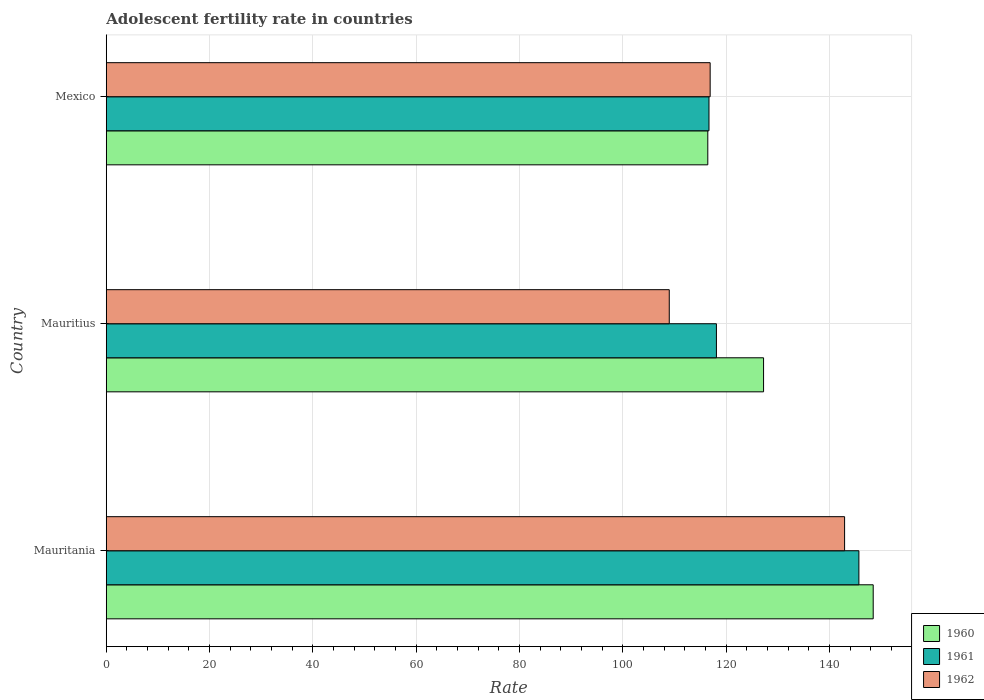Are the number of bars per tick equal to the number of legend labels?
Keep it short and to the point. Yes. Are the number of bars on each tick of the Y-axis equal?
Your answer should be very brief. Yes. What is the label of the 3rd group of bars from the top?
Offer a terse response. Mauritania. What is the adolescent fertility rate in 1962 in Mauritania?
Offer a very short reply. 142.93. Across all countries, what is the maximum adolescent fertility rate in 1960?
Provide a short and direct response. 148.47. Across all countries, what is the minimum adolescent fertility rate in 1960?
Your answer should be compact. 116.45. In which country was the adolescent fertility rate in 1960 maximum?
Offer a very short reply. Mauritania. In which country was the adolescent fertility rate in 1962 minimum?
Offer a terse response. Mauritius. What is the total adolescent fertility rate in 1960 in the graph?
Make the answer very short. 392.17. What is the difference between the adolescent fertility rate in 1961 in Mauritania and that in Mauritius?
Your answer should be compact. 27.58. What is the difference between the adolescent fertility rate in 1962 in Mauritania and the adolescent fertility rate in 1960 in Mexico?
Keep it short and to the point. 26.48. What is the average adolescent fertility rate in 1962 per country?
Make the answer very short. 122.95. What is the difference between the adolescent fertility rate in 1962 and adolescent fertility rate in 1960 in Mauritania?
Keep it short and to the point. -5.54. What is the ratio of the adolescent fertility rate in 1960 in Mauritania to that in Mexico?
Give a very brief answer. 1.27. Is the adolescent fertility rate in 1962 in Mauritius less than that in Mexico?
Provide a short and direct response. Yes. What is the difference between the highest and the second highest adolescent fertility rate in 1962?
Offer a very short reply. 26.02. What is the difference between the highest and the lowest adolescent fertility rate in 1960?
Your answer should be very brief. 32.02. In how many countries, is the adolescent fertility rate in 1962 greater than the average adolescent fertility rate in 1962 taken over all countries?
Offer a very short reply. 1. Is the sum of the adolescent fertility rate in 1962 in Mauritania and Mauritius greater than the maximum adolescent fertility rate in 1960 across all countries?
Ensure brevity in your answer.  Yes. What does the 2nd bar from the top in Mauritania represents?
Your response must be concise. 1961. What does the 2nd bar from the bottom in Mauritania represents?
Offer a very short reply. 1961. How many bars are there?
Provide a succinct answer. 9. Are all the bars in the graph horizontal?
Offer a very short reply. Yes. What is the difference between two consecutive major ticks on the X-axis?
Provide a succinct answer. 20. Does the graph contain any zero values?
Keep it short and to the point. No. Does the graph contain grids?
Make the answer very short. Yes. Where does the legend appear in the graph?
Give a very brief answer. Bottom right. How many legend labels are there?
Offer a terse response. 3. How are the legend labels stacked?
Make the answer very short. Vertical. What is the title of the graph?
Make the answer very short. Adolescent fertility rate in countries. What is the label or title of the X-axis?
Give a very brief answer. Rate. What is the Rate of 1960 in Mauritania?
Offer a terse response. 148.47. What is the Rate in 1961 in Mauritania?
Give a very brief answer. 145.7. What is the Rate in 1962 in Mauritania?
Offer a very short reply. 142.93. What is the Rate of 1960 in Mauritius?
Offer a very short reply. 127.25. What is the Rate of 1961 in Mauritius?
Your answer should be very brief. 118.12. What is the Rate of 1962 in Mauritius?
Ensure brevity in your answer.  108.99. What is the Rate of 1960 in Mexico?
Provide a succinct answer. 116.45. What is the Rate of 1961 in Mexico?
Offer a terse response. 116.68. What is the Rate in 1962 in Mexico?
Keep it short and to the point. 116.91. Across all countries, what is the maximum Rate of 1960?
Keep it short and to the point. 148.47. Across all countries, what is the maximum Rate in 1961?
Your answer should be compact. 145.7. Across all countries, what is the maximum Rate in 1962?
Provide a short and direct response. 142.93. Across all countries, what is the minimum Rate of 1960?
Make the answer very short. 116.45. Across all countries, what is the minimum Rate in 1961?
Your response must be concise. 116.68. Across all countries, what is the minimum Rate in 1962?
Your answer should be compact. 108.99. What is the total Rate of 1960 in the graph?
Your answer should be compact. 392.17. What is the total Rate in 1961 in the graph?
Ensure brevity in your answer.  380.5. What is the total Rate in 1962 in the graph?
Offer a very short reply. 368.84. What is the difference between the Rate of 1960 in Mauritania and that in Mauritius?
Your answer should be compact. 21.23. What is the difference between the Rate of 1961 in Mauritania and that in Mauritius?
Offer a terse response. 27.58. What is the difference between the Rate in 1962 in Mauritania and that in Mauritius?
Offer a very short reply. 33.94. What is the difference between the Rate in 1960 in Mauritania and that in Mexico?
Your answer should be very brief. 32.02. What is the difference between the Rate in 1961 in Mauritania and that in Mexico?
Your answer should be compact. 29.02. What is the difference between the Rate of 1962 in Mauritania and that in Mexico?
Make the answer very short. 26.02. What is the difference between the Rate in 1960 in Mauritius and that in Mexico?
Give a very brief answer. 10.8. What is the difference between the Rate in 1961 in Mauritius and that in Mexico?
Provide a short and direct response. 1.44. What is the difference between the Rate of 1962 in Mauritius and that in Mexico?
Keep it short and to the point. -7.92. What is the difference between the Rate of 1960 in Mauritania and the Rate of 1961 in Mauritius?
Provide a succinct answer. 30.35. What is the difference between the Rate of 1960 in Mauritania and the Rate of 1962 in Mauritius?
Your answer should be compact. 39.48. What is the difference between the Rate in 1961 in Mauritania and the Rate in 1962 in Mauritius?
Offer a very short reply. 36.71. What is the difference between the Rate in 1960 in Mauritania and the Rate in 1961 in Mexico?
Your answer should be very brief. 31.79. What is the difference between the Rate in 1960 in Mauritania and the Rate in 1962 in Mexico?
Your answer should be very brief. 31.56. What is the difference between the Rate in 1961 in Mauritania and the Rate in 1962 in Mexico?
Keep it short and to the point. 28.79. What is the difference between the Rate of 1960 in Mauritius and the Rate of 1961 in Mexico?
Provide a succinct answer. 10.57. What is the difference between the Rate in 1960 in Mauritius and the Rate in 1962 in Mexico?
Provide a succinct answer. 10.34. What is the difference between the Rate of 1961 in Mauritius and the Rate of 1962 in Mexico?
Make the answer very short. 1.21. What is the average Rate in 1960 per country?
Give a very brief answer. 130.72. What is the average Rate in 1961 per country?
Make the answer very short. 126.83. What is the average Rate of 1962 per country?
Ensure brevity in your answer.  122.95. What is the difference between the Rate of 1960 and Rate of 1961 in Mauritania?
Your answer should be compact. 2.77. What is the difference between the Rate of 1960 and Rate of 1962 in Mauritania?
Your answer should be compact. 5.54. What is the difference between the Rate of 1961 and Rate of 1962 in Mauritania?
Provide a short and direct response. 2.77. What is the difference between the Rate of 1960 and Rate of 1961 in Mauritius?
Provide a succinct answer. 9.13. What is the difference between the Rate of 1960 and Rate of 1962 in Mauritius?
Offer a very short reply. 18.25. What is the difference between the Rate of 1961 and Rate of 1962 in Mauritius?
Keep it short and to the point. 9.13. What is the difference between the Rate in 1960 and Rate in 1961 in Mexico?
Give a very brief answer. -0.23. What is the difference between the Rate in 1960 and Rate in 1962 in Mexico?
Provide a succinct answer. -0.46. What is the difference between the Rate of 1961 and Rate of 1962 in Mexico?
Your answer should be compact. -0.23. What is the ratio of the Rate of 1960 in Mauritania to that in Mauritius?
Your answer should be compact. 1.17. What is the ratio of the Rate in 1961 in Mauritania to that in Mauritius?
Your answer should be very brief. 1.23. What is the ratio of the Rate of 1962 in Mauritania to that in Mauritius?
Give a very brief answer. 1.31. What is the ratio of the Rate of 1960 in Mauritania to that in Mexico?
Give a very brief answer. 1.27. What is the ratio of the Rate of 1961 in Mauritania to that in Mexico?
Offer a terse response. 1.25. What is the ratio of the Rate of 1962 in Mauritania to that in Mexico?
Your response must be concise. 1.22. What is the ratio of the Rate in 1960 in Mauritius to that in Mexico?
Your answer should be compact. 1.09. What is the ratio of the Rate of 1961 in Mauritius to that in Mexico?
Provide a short and direct response. 1.01. What is the ratio of the Rate of 1962 in Mauritius to that in Mexico?
Offer a very short reply. 0.93. What is the difference between the highest and the second highest Rate of 1960?
Your answer should be very brief. 21.23. What is the difference between the highest and the second highest Rate of 1961?
Offer a very short reply. 27.58. What is the difference between the highest and the second highest Rate in 1962?
Offer a terse response. 26.02. What is the difference between the highest and the lowest Rate in 1960?
Provide a succinct answer. 32.02. What is the difference between the highest and the lowest Rate in 1961?
Your answer should be very brief. 29.02. What is the difference between the highest and the lowest Rate in 1962?
Provide a short and direct response. 33.94. 